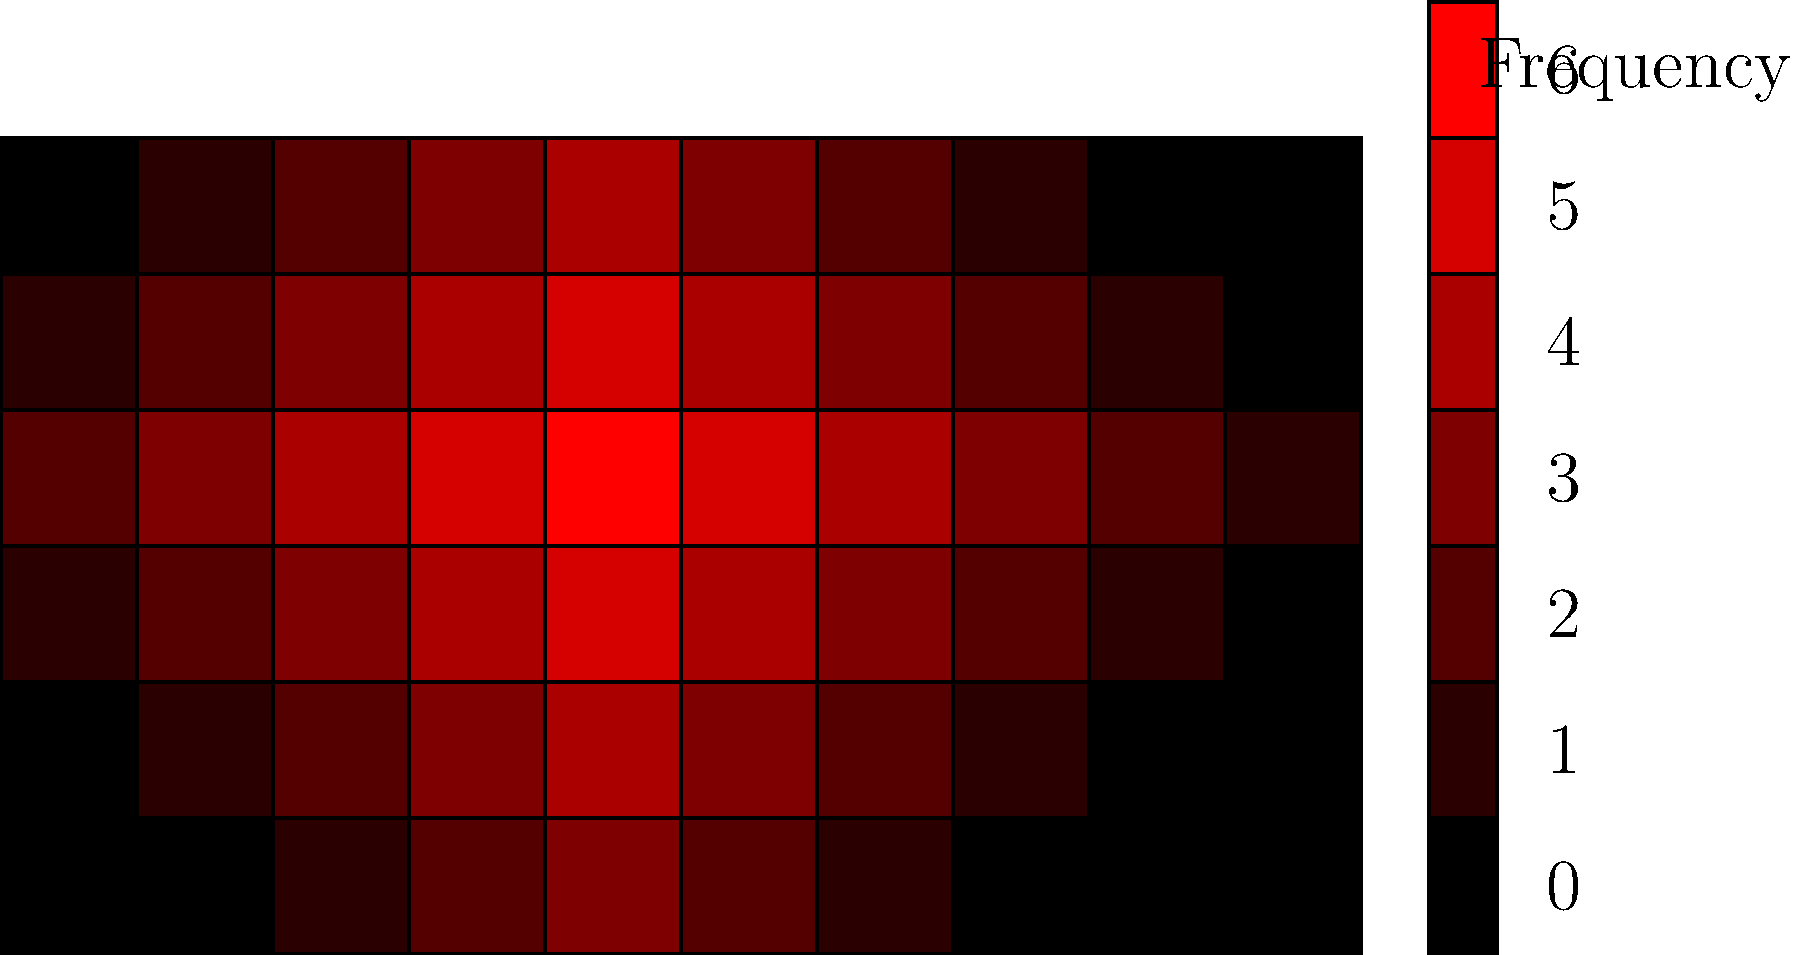Based on the heat map of player positions on the soccer field, which area of the field shows the highest concentration of player activity, and what tactical implications might this have for the team's playing style? To answer this question, we need to analyze the heat map systematically:

1. Understand the heat map: The darker red areas indicate higher player activity, while lighter or white areas show less activity.

2. Identify the area of highest concentration:
   - The darkest red area is located slightly to the right of the center circle, just inside the opponent's half.

3. Quantify the activity:
   - The legend shows that the darkest red corresponds to a frequency of 6, the highest on the scale.

4. Analyze the tactical implications:
   a) Central focus: The high activity in the central area suggests the team prioritizes control of the middle of the field.
   
   b) Attacking bias: The concentration being just inside the opponent's half indicates an attacking mindset.
   
   c) Possession play: High activity in this area often correlates with a possession-based style, as teams try to build attacks from this position.
   
   d) Pressing strategy: It could also indicate a high pressing game, with the team trying to win the ball back quickly in advanced positions.
   
   e) Defensive shape: The team's defensive line likely sits relatively high to support this active central area.
   
   f) Wing play: There's less activity on the wings, suggesting the team might not rely heavily on wide attacks.

5. Consider the limitations:
   - This heat map shows aggregate data and doesn't account for different game situations or opponent tactics.

In conclusion, the highest concentration of player activity is in the central area just inside the opponent's half. This suggests a team that likely employs a possession-based, centrally-focused attacking style with a high pressing defensive strategy.
Answer: Central area just inside opponent's half; indicates possession-based, centrally-focused attacking style with high pressing. 